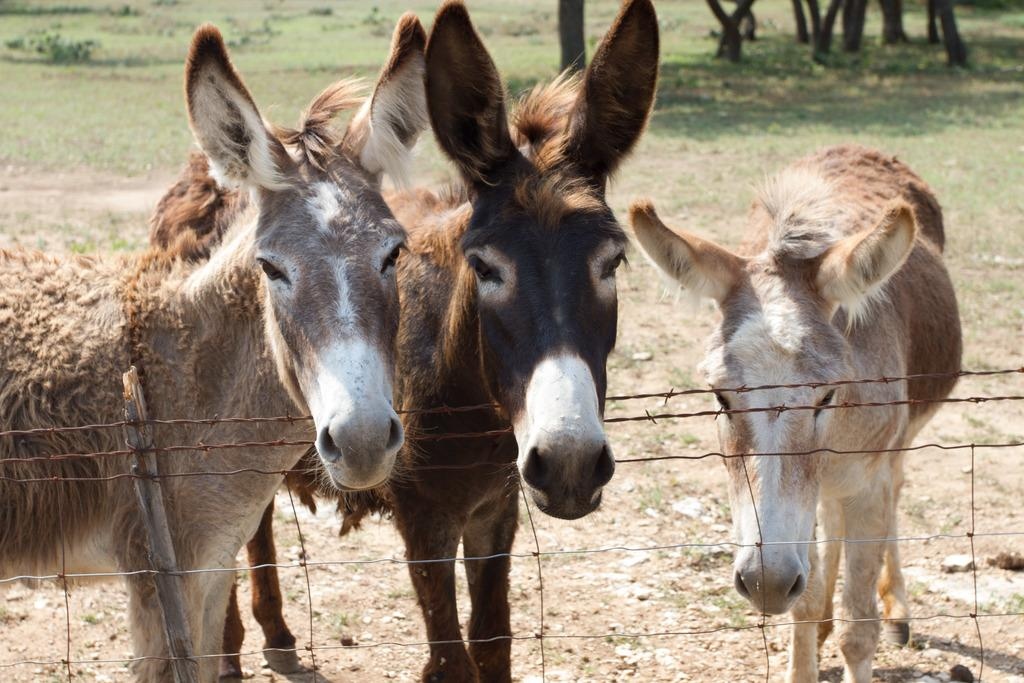What animals can be seen in the foreground of the picture? There are donkeys in the foreground of the picture. What is located in the foreground of the picture along with the donkeys? There is fencing and soil present in the foreground of the picture. What can be seen in the background of the picture? There are trees, plants, and grass present in the background of the picture. What type of corn can be seen growing in the background of the image? There is no corn present in the image; it features donkeys, fencing, soil, trees, plants, and grass in the background. 